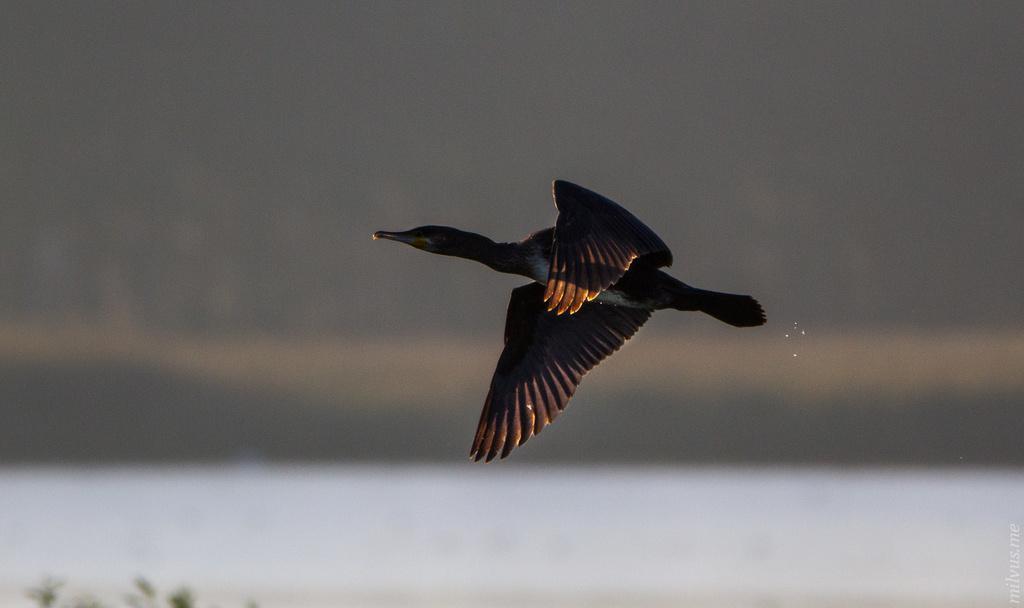In one or two sentences, can you explain what this image depicts? Here in this picture we can see a black colored bird flying in the air over there. 